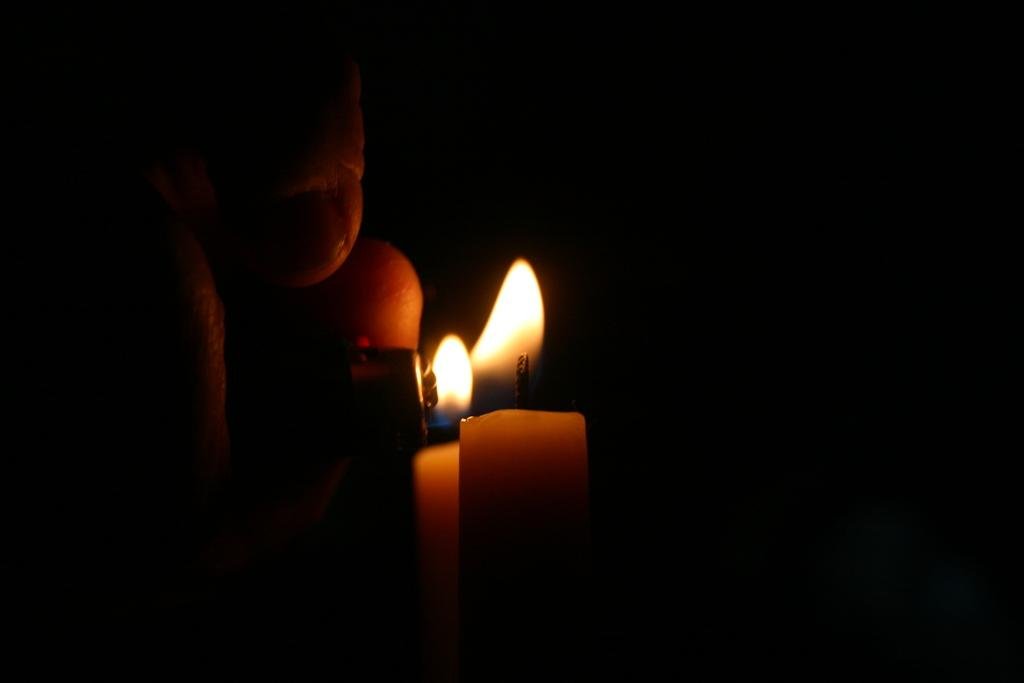What body part is visible in the image? There is a person's hand in the image. What object is present that can be used for lighting? There is a lighter in the image. What object is present that can be lit using the lighter? There is a candle in the image. How would you describe the lighting conditions in the image? The background of the image is dark. What type of substance is the toad using to light the candles in the image? There is no toad or candles present in the image; it only features a person's hand, a lighter, and a candle. 